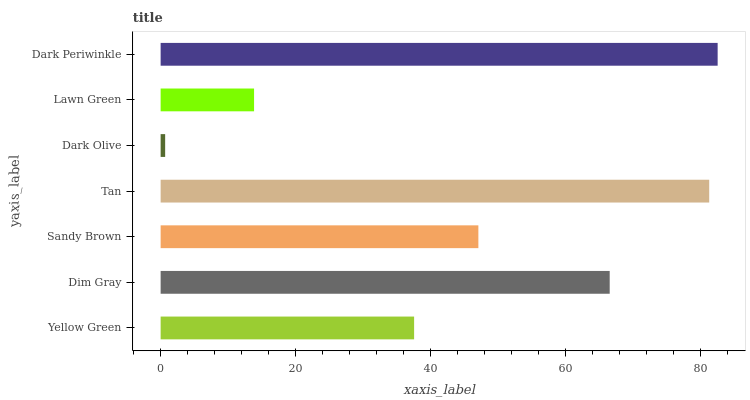Is Dark Olive the minimum?
Answer yes or no. Yes. Is Dark Periwinkle the maximum?
Answer yes or no. Yes. Is Dim Gray the minimum?
Answer yes or no. No. Is Dim Gray the maximum?
Answer yes or no. No. Is Dim Gray greater than Yellow Green?
Answer yes or no. Yes. Is Yellow Green less than Dim Gray?
Answer yes or no. Yes. Is Yellow Green greater than Dim Gray?
Answer yes or no. No. Is Dim Gray less than Yellow Green?
Answer yes or no. No. Is Sandy Brown the high median?
Answer yes or no. Yes. Is Sandy Brown the low median?
Answer yes or no. Yes. Is Lawn Green the high median?
Answer yes or no. No. Is Dark Olive the low median?
Answer yes or no. No. 